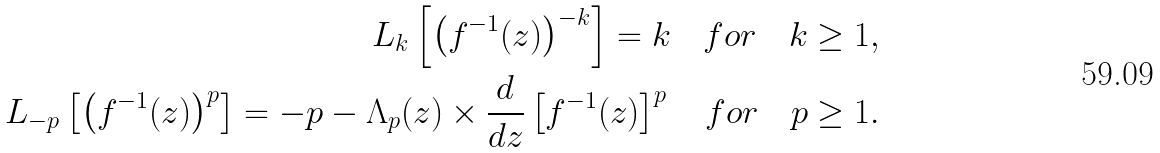Convert formula to latex. <formula><loc_0><loc_0><loc_500><loc_500>L _ { k } \left [ \left ( f ^ { - 1 } ( z ) \right ) ^ { - k } \right ] = k \quad f o r \quad k \geq 1 , \\ L _ { - p } \left [ \left ( f ^ { - 1 } ( z ) \right ) ^ { p } \right ] = - p - \Lambda _ { p } ( z ) \times \frac { d } { d z } \left [ f ^ { - 1 } ( z ) \right ] ^ { p } \quad f o r \quad p \geq 1 .</formula> 